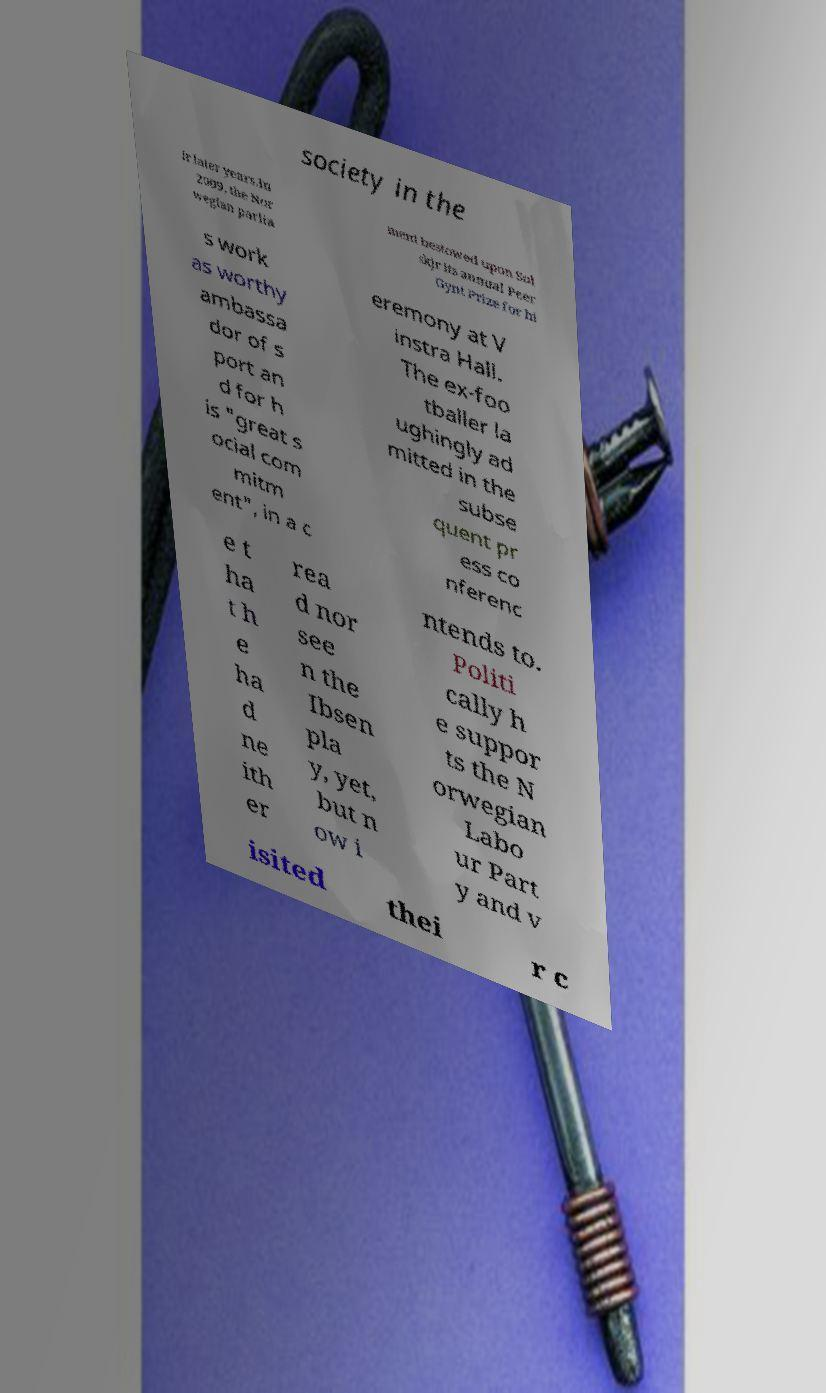I need the written content from this picture converted into text. Can you do that? society in the ir later years.In 2009, the Nor wegian parlia ment bestowed upon Sol skjr its annual Peer Gynt Prize for hi s work as worthy ambassa dor of s port an d for h is "great s ocial com mitm ent", in a c eremony at V instra Hall. The ex-foo tballer la ughingly ad mitted in the subse quent pr ess co nferenc e t ha t h e ha d ne ith er rea d nor see n the Ibsen pla y, yet, but n ow i ntends to. Politi cally h e suppor ts the N orwegian Labo ur Part y and v isited thei r c 